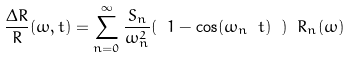<formula> <loc_0><loc_0><loc_500><loc_500>\frac { \Delta R } { R } ( \omega , t ) = \sum _ { n = 0 } ^ { \infty } \frac { S _ { n } } { \omega _ { n } ^ { 2 } } ( \ 1 - \cos ( \omega _ { n } \ t ) \ ) \ R _ { n } ( \omega )</formula> 